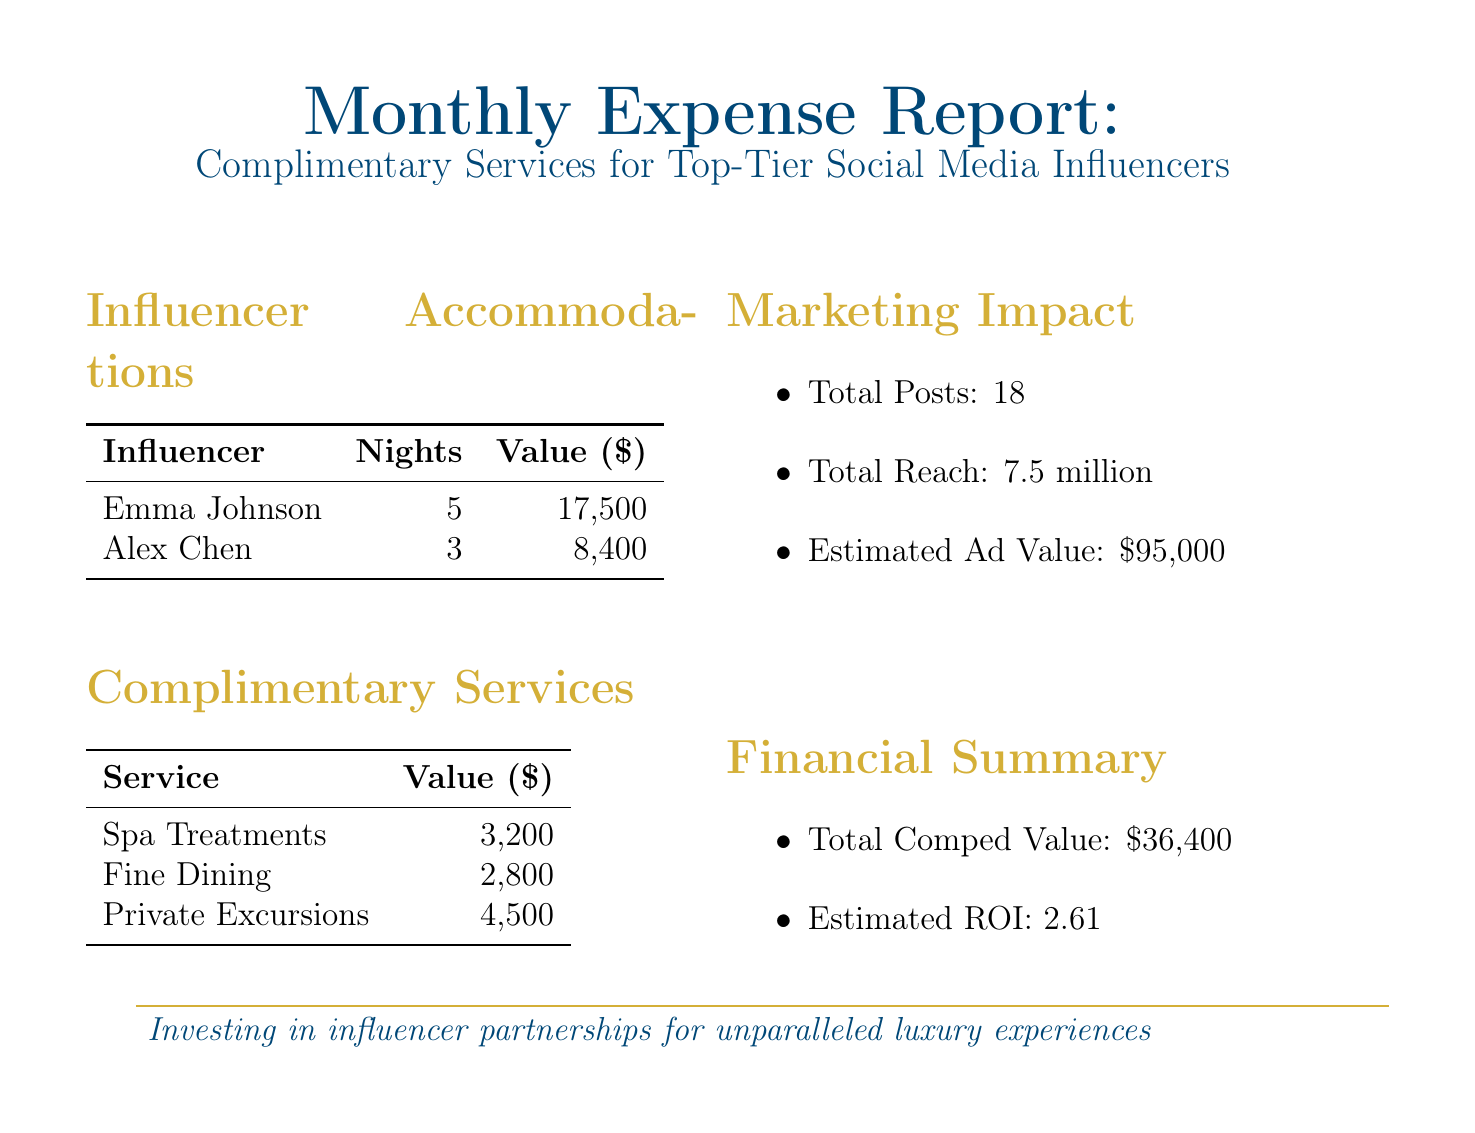What is the company name? The company name is mentioned in the report header at the top of the document.
Answer: Luxe Global Resorts How many followers does Emma Johnson have? The number of followers for Emma Johnson is listed in her accommodations section.
Answer: 2500000 What is the total value of complimentary services? The total value of complimentary services is summarized in the financial summary section of the document.
Answer: 36400 How many nights were comped for Alex Chen? The number of nights comped for Alex Chen is specified in the influencer accommodations section.
Answer: 3 What is the estimated ROI mentioned in the financial summary? The estimated ROI can be found in the financial summary of the document.
Answer: 2.61 What is the total reach of the influencers' posts? The total reach is detailed in the marketing impact section of the document.
Answer: 7500000 What is the nightly rate for the Presidential Suite? The nightly rate for the Presidential Suite is provided in the influencer accommodations section.
Answer: 3500 What type of room did Alex Chen stay in? The type of room for Alex Chen is listed in the accommodations section of the document.
Answer: Oceanview Villa How many total posts were made by the influencers? The total posts made by the influencers is outlined in the marketing impact section.
Answer: 18 